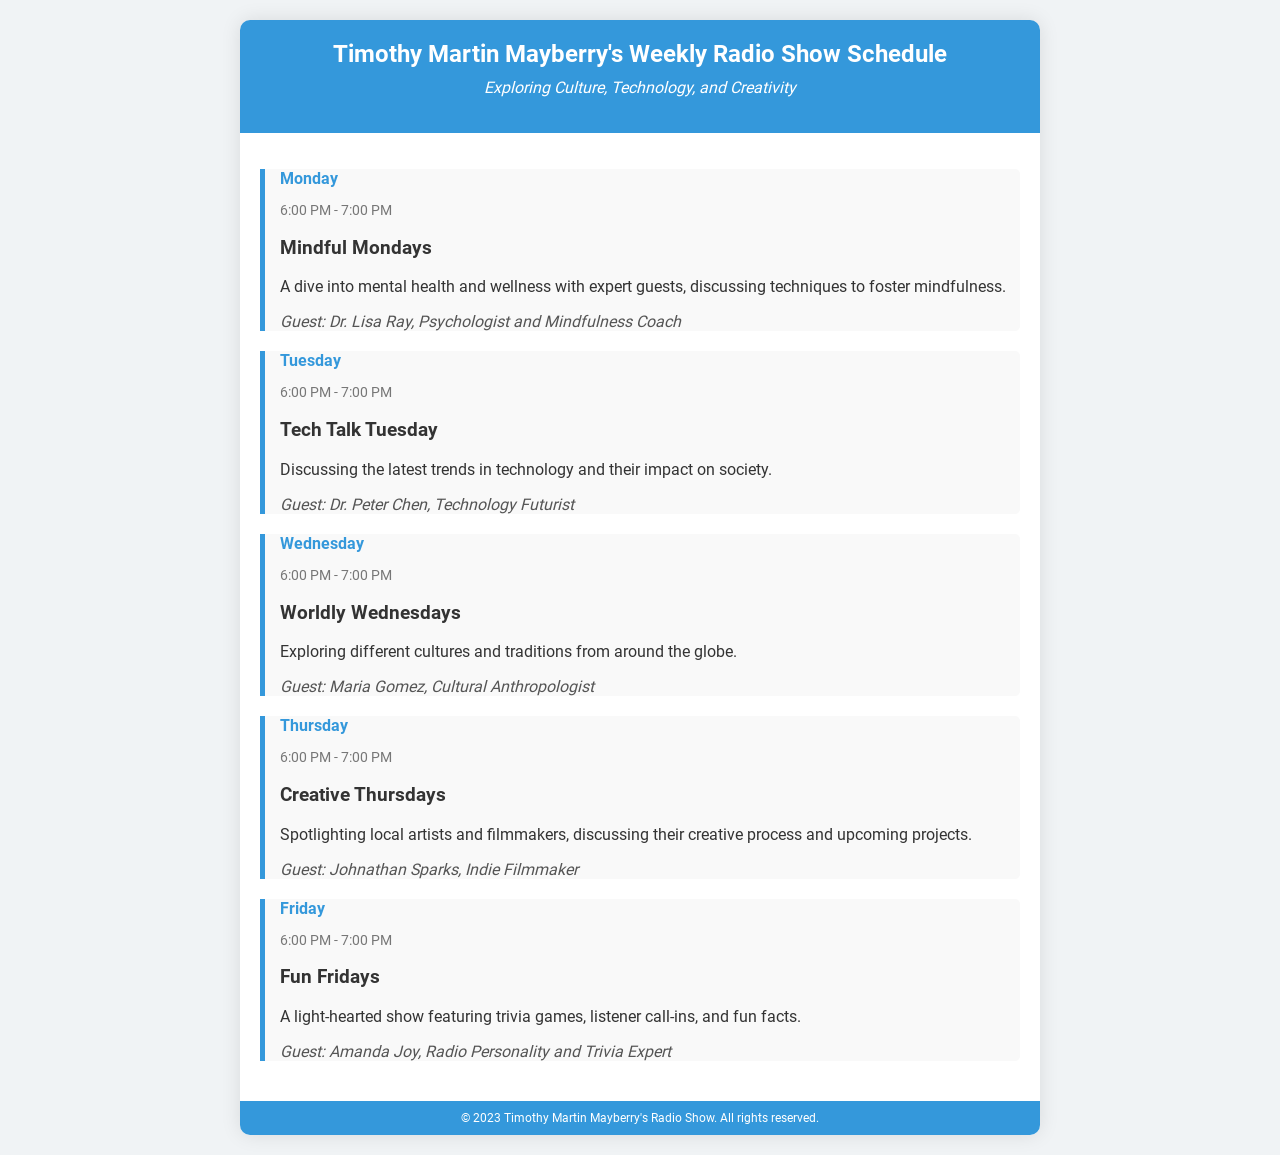What is the name of the show? The title of the show is provided in the header of the document.
Answer: Timothy Martin Mayberry's Weekly Radio Show Schedule What day features "Mindful Mondays"? The specific day for "Mindful Mondays" can be found under the relevant section.
Answer: Monday Who is the guest on "Tech Talk Tuesday"? The guest for "Tech Talk Tuesday" is mentioned directly in the description of that day's show.
Answer: Dr. Peter Chen What time does "Fun Fridays" occur? The time for "Fun Fridays" is listed in the schedule for that day.
Answer: 6:00 PM - 7:00 PM How many different shows are scheduled per week? The number of shows is indicated by the number of distinct days mentioned in the schedule.
Answer: 5 